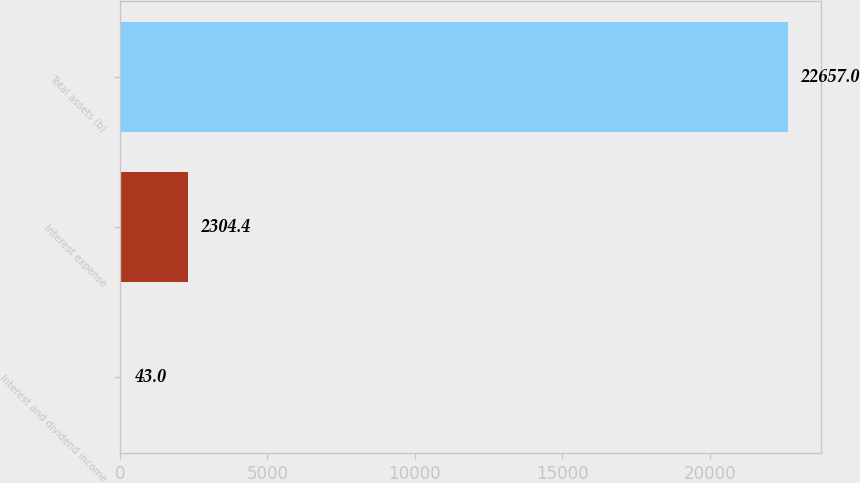<chart> <loc_0><loc_0><loc_500><loc_500><bar_chart><fcel>Interest and dividend income<fcel>Interest expense<fcel>Total assets (b)<nl><fcel>43<fcel>2304.4<fcel>22657<nl></chart> 